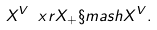<formula> <loc_0><loc_0><loc_500><loc_500>X ^ { V } \ x r X _ { + } \S m a s h X ^ { V } .</formula> 